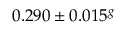<formula> <loc_0><loc_0><loc_500><loc_500>0 . 2 9 0 \pm 0 . 0 1 5 ^ { g }</formula> 